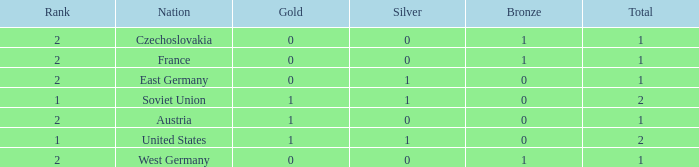What is the highest rank of Austria, which had less than 0 silvers? None. 